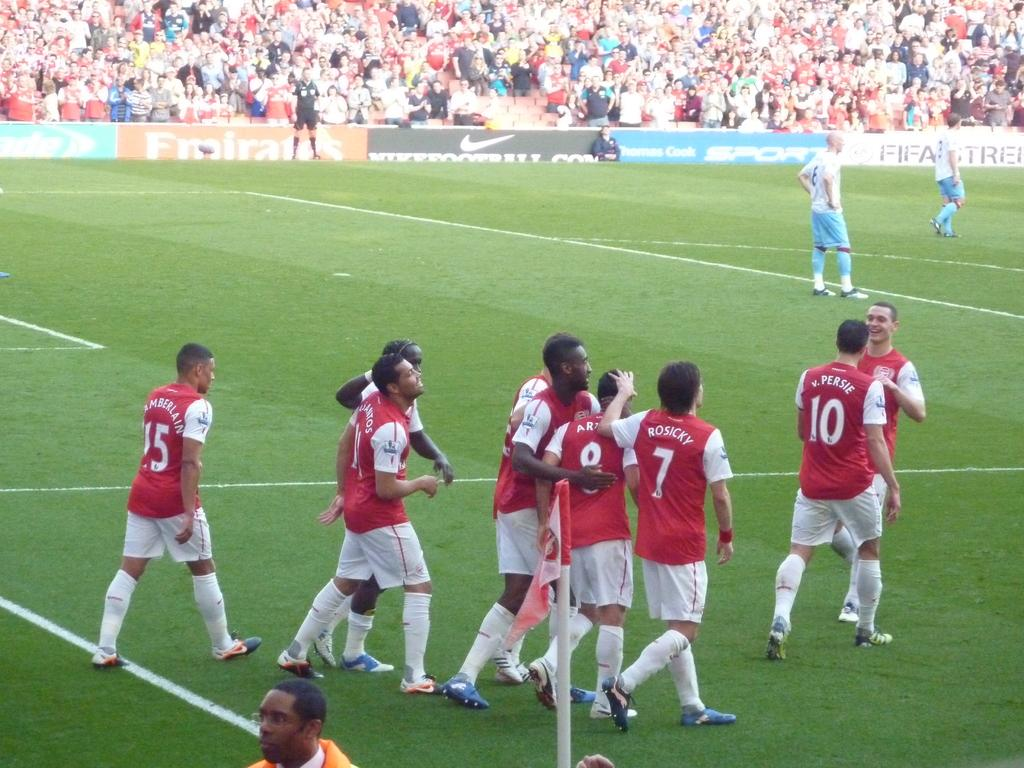<image>
Offer a succinct explanation of the picture presented. Persie and Rosicky walk on the field with a group of their red-shirted teammates. 